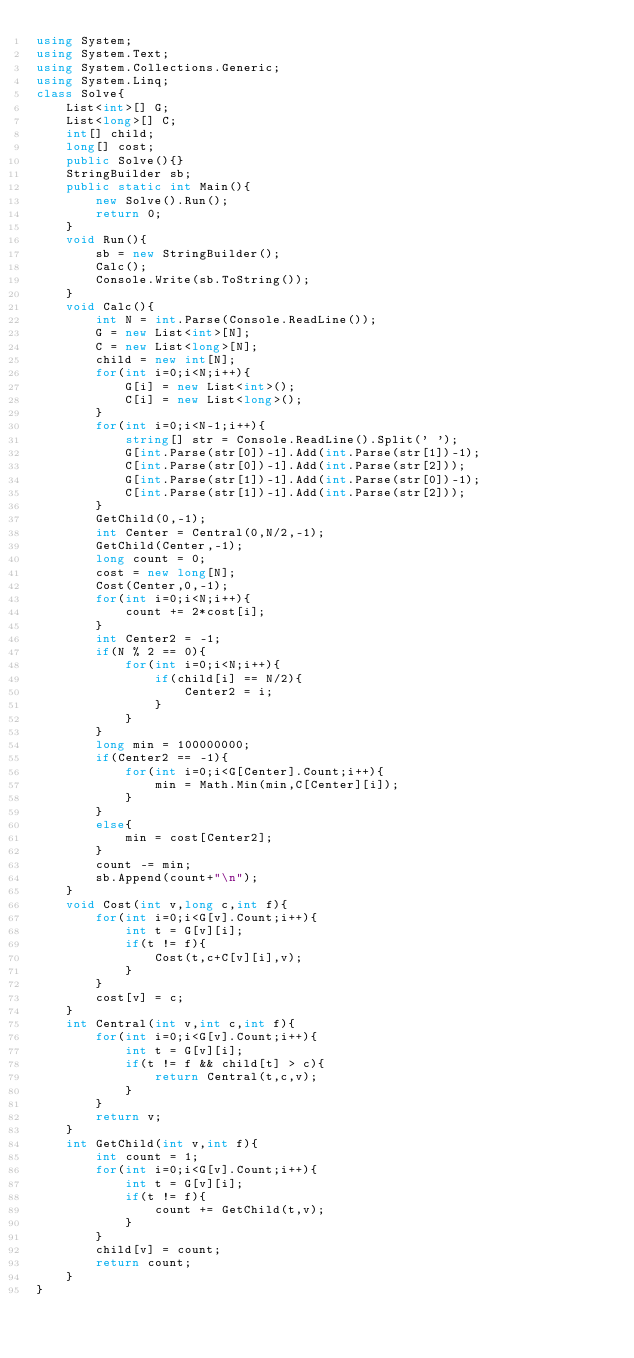<code> <loc_0><loc_0><loc_500><loc_500><_C#_>using System;
using System.Text;
using System.Collections.Generic;
using System.Linq;
class Solve{
    List<int>[] G;
    List<long>[] C;
    int[] child;
    long[] cost;
    public Solve(){}
    StringBuilder sb;
    public static int Main(){
        new Solve().Run();
        return 0;
    }
    void Run(){
        sb = new StringBuilder();
        Calc();
        Console.Write(sb.ToString());
    }
    void Calc(){
        int N = int.Parse(Console.ReadLine());
        G = new List<int>[N];
        C = new List<long>[N];
        child = new int[N];
        for(int i=0;i<N;i++){
            G[i] = new List<int>();
            C[i] = new List<long>();
        }
        for(int i=0;i<N-1;i++){
            string[] str = Console.ReadLine().Split(' ');
            G[int.Parse(str[0])-1].Add(int.Parse(str[1])-1);
            C[int.Parse(str[0])-1].Add(int.Parse(str[2]));
            G[int.Parse(str[1])-1].Add(int.Parse(str[0])-1);
            C[int.Parse(str[1])-1].Add(int.Parse(str[2]));
        }
        GetChild(0,-1);
        int Center = Central(0,N/2,-1);
        GetChild(Center,-1);
        long count = 0;
        cost = new long[N];
        Cost(Center,0,-1);
        for(int i=0;i<N;i++){
            count += 2*cost[i];
        }
        int Center2 = -1;
        if(N % 2 == 0){
            for(int i=0;i<N;i++){
                if(child[i] == N/2){
                    Center2 = i;
                }
            }
        }
        long min = 100000000;
        if(Center2 == -1){
            for(int i=0;i<G[Center].Count;i++){
                min = Math.Min(min,C[Center][i]);
            }
        }
        else{
            min = cost[Center2];
        }
        count -= min;
        sb.Append(count+"\n");
    }
    void Cost(int v,long c,int f){
        for(int i=0;i<G[v].Count;i++){
            int t = G[v][i];
            if(t != f){
                Cost(t,c+C[v][i],v);
            }
        }
        cost[v] = c;
    }
    int Central(int v,int c,int f){
        for(int i=0;i<G[v].Count;i++){
            int t = G[v][i];
            if(t != f && child[t] > c){
                return Central(t,c,v);
            }
        }
        return v;
    }
    int GetChild(int v,int f){
        int count = 1;
        for(int i=0;i<G[v].Count;i++){
            int t = G[v][i];
            if(t != f){
                count += GetChild(t,v);
            }
        }
        child[v] = count;
        return count;
    }
}</code> 